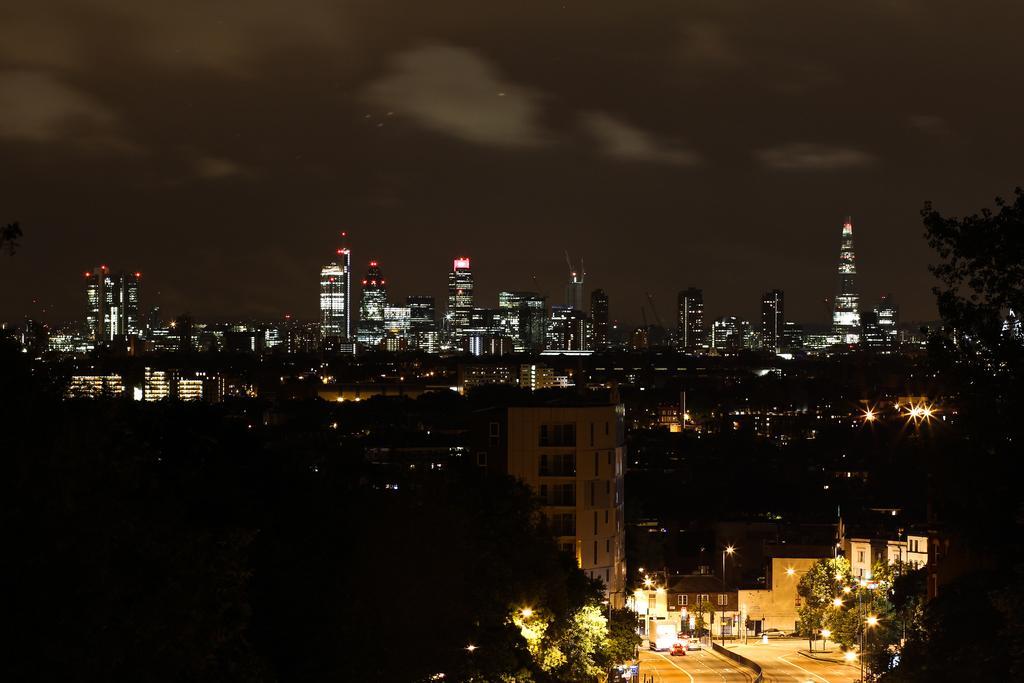Please provide a concise description of this image. The image is captured in the nighttime. It is a beautiful city with lot of buildings and the buildings are filled with beautiful lights and the roads are empty and beside the roads there are few street lights. Behind the street lights there are a lot of trees. 